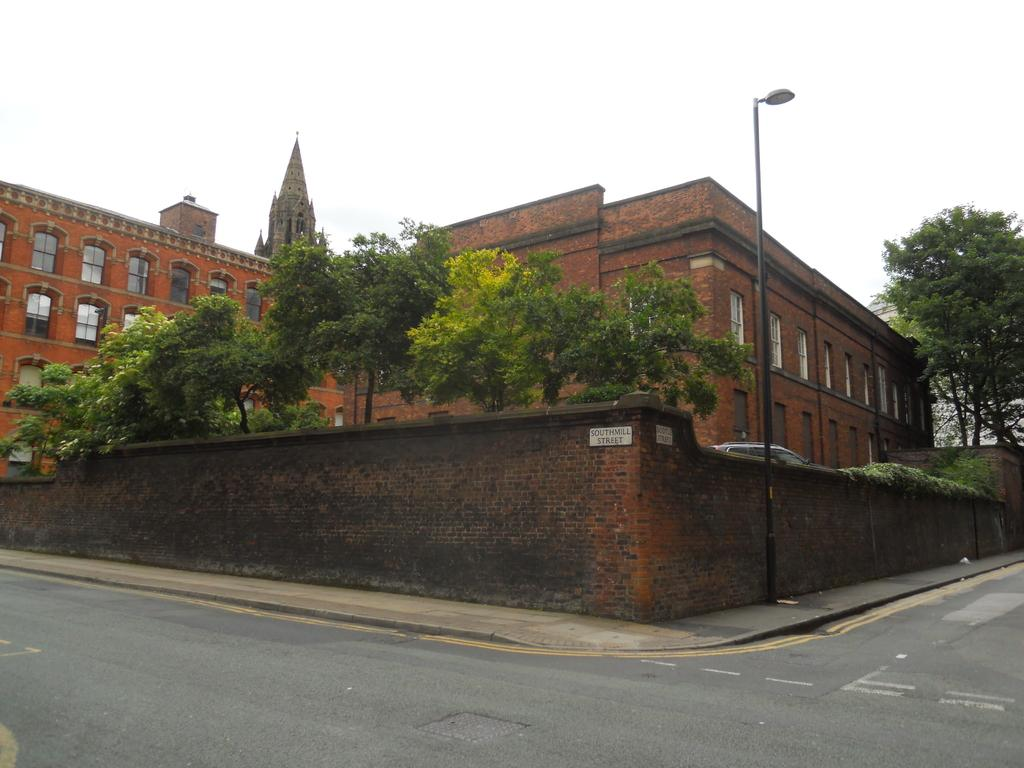What type of structures can be seen in the image? There are buildings in the image. What other natural elements are present in the image? There are trees in the image. What is at the bottom of the image? There is a road and a wall at the bottom of the image. What object can be seen standing upright in the image? There is a pole in the image. What mode of transportation is visible in the image? There is a car in the image. What part of the natural environment is visible in the background of the image? The sky is visible in the background of the image. What type of meal is being prepared in the image? There is no meal being prepared in the image; it features buildings, trees, a road, a wall, a pole, a car, and the sky. What team is playing in the image? There is no team or sports activity depicted in the image. 